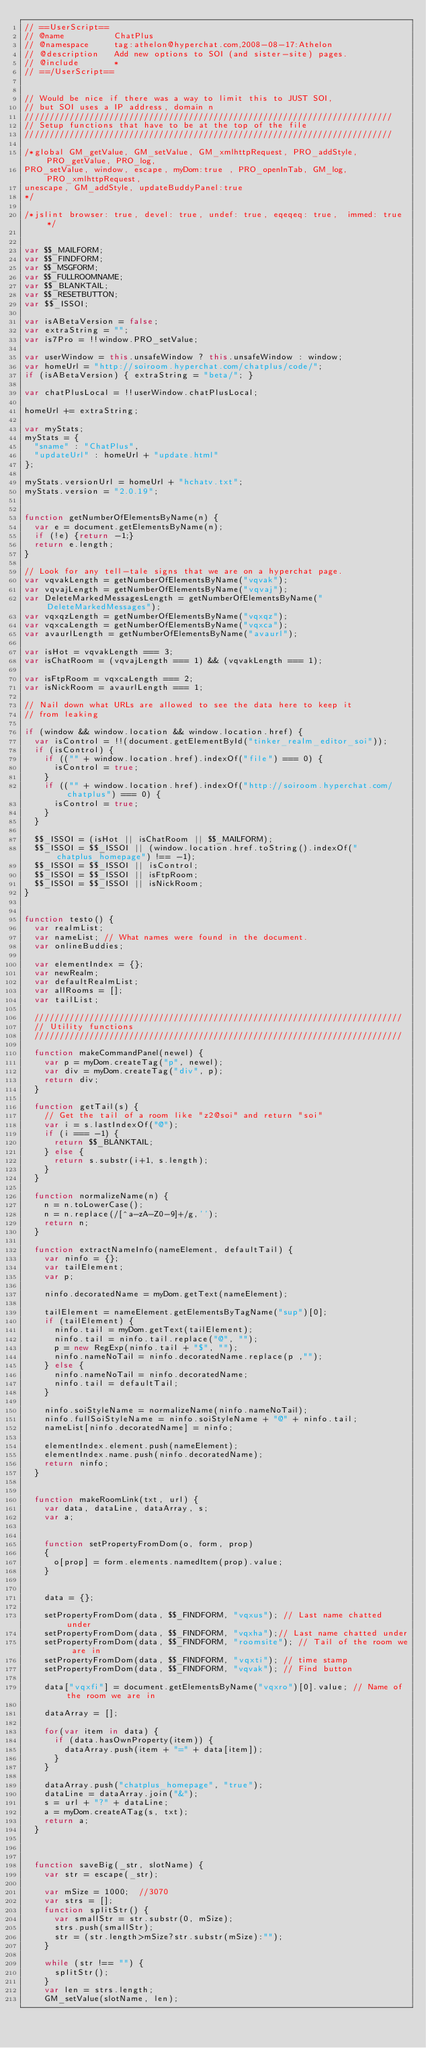<code> <loc_0><loc_0><loc_500><loc_500><_JavaScript_>// ==UserScript==
// @name          ChatPlus
// @namespace     tag:athelon@hyperchat.com,2008-08-17:Athelon
// @description   Add new options to SOI (and sister-site) pages.
// @include       *
// ==/UserScript==


// Would be nice if there was a way to limit this to JUST SOI,
// but SOI uses a IP address, domain n
//////////////////////////////////////////////////////////////////////////
// Setup functions that have to be at the top of the file
//////////////////////////////////////////////////////////////////////////

/*global GM_getValue, GM_setValue, GM_xmlhttpRequest, PRO_addStyle, PRO_getValue, PRO_log,
PRO_setValue, window, escape, myDom:true , PRO_openInTab, GM_log, PRO_xmlhttpRequest,
unescape, GM_addStyle, updateBuddyPanel:true
*/

/*jslint browser: true, devel: true, undef: true, eqeqeq: true,  immed: true */


var $$_MAILFORM;
var $$_FINDFORM;
var $$_MSGFORM;
var $$_FULLROOMNAME;
var $$_BLANKTAIL;
var $$_RESETBUTTON;
var $$_ISSOI;

var isABetaVersion = false;
var extraString = "";
var is7Pro = !!window.PRO_setValue;

var userWindow = this.unsafeWindow ? this.unsafeWindow : window;
var homeUrl = "http://soiroom.hyperchat.com/chatplus/code/";
if (isABetaVersion) { extraString = "beta/"; }

var chatPlusLocal = !!userWindow.chatPlusLocal;

homeUrl += extraString;

var myStats;
myStats = {
  "sname" : "ChatPlus",
  "updateUrl" : homeUrl + "update.html"
};

myStats.versionUrl = homeUrl + "hchatv.txt";
myStats.version = "2.0.19";


function getNumberOfElementsByName(n) {
  var e = document.getElementsByName(n);
  if (!e) {return -1;}
  return e.length;
}

// Look for any tell-tale signs that we are on a hyperchat page.
var vqvakLength = getNumberOfElementsByName("vqvak");
var vqvajLength = getNumberOfElementsByName("vqvaj");
var DeleteMarkedMessagesLength = getNumberOfElementsByName("DeleteMarkedMessages");
var vqxqzLength = getNumberOfElementsByName("vqxqz");
var vqxcaLength = getNumberOfElementsByName("vqxca");
var avaurlLength = getNumberOfElementsByName("avaurl");

var isHot = vqvakLength === 3;
var isChatRoom = (vqvajLength === 1) && (vqvakLength === 1);

var isFtpRoom = vqxcaLength === 2;
var isNickRoom = avaurlLength === 1;

// Nail down what URLs are allowed to see the data here to keep it
// from leaking

if (window && window.location && window.location.href) {
  var isControl = !!(document.getElementById("tinker_realm_editor_soi"));
  if (isControl) {
    if (("" + window.location.href).indexOf("file") === 0) {
      isControl = true;
    }
    if (("" + window.location.href).indexOf("http://soiroom.hyperchat.com/chatplus") === 0) {
      isControl = true;
    }
  }
  
  $$_ISSOI = (isHot || isChatRoom || $$_MAILFORM);
  $$_ISSOI = $$_ISSOI || (window.location.href.toString().indexOf("chatplus_homepage") !== -1);
  $$_ISSOI = $$_ISSOI || isControl;
  $$_ISSOI = $$_ISSOI || isFtpRoom;
  $$_ISSOI = $$_ISSOI || isNickRoom;
}


function testo() {
  var realmList;
  var nameList; // What names were found in the document.
  var onlineBuddies;
  
  var elementIndex = {};
  var newRealm;
  var defaultRealmList;
  var allRooms = [];
  var tailList;
  
  //////////////////////////////////////////////////////////////////////////
  // Utility functions
  //////////////////////////////////////////////////////////////////////////
  
  function makeCommandPanel(newel) {
    var p = myDom.createTag("p", newel);
    var div = myDom.createTag("div", p);
    return div;
  }
  
  function getTail(s) {
    // Get the tail of a room like "z2@soi" and return "soi"
    var i = s.lastIndexOf("@");
    if (i === -1) {
      return $$_BLANKTAIL;
    } else {
      return s.substr(i+1, s.length);
    }
  }
  
  function normalizeName(n) {
    n = n.toLowerCase();
    n = n.replace(/[^a-zA-Z0-9]+/g,'');
    return n;
  }
    
  function extractNameInfo(nameElement, defaultTail) {
    var ninfo = {};
    var tailElement;
    var p;
    
    ninfo.decoratedName = myDom.getText(nameElement);
    
    tailElement = nameElement.getElementsByTagName("sup")[0];
    if (tailElement) {
      ninfo.tail = myDom.getText(tailElement);
      ninfo.tail = ninfo.tail.replace("@", "");
      p = new RegExp(ninfo.tail + "$", "");
      ninfo.nameNoTail = ninfo.decoratedName.replace(p ,"");
    } else {
      ninfo.nameNoTail = ninfo.decoratedName;
      ninfo.tail = defaultTail;
    }
    
    ninfo.soiStyleName = normalizeName(ninfo.nameNoTail);
    ninfo.fullSoiStyleName = ninfo.soiStyleName + "@" + ninfo.tail;
    nameList[ninfo.decoratedName] = ninfo;
    
    elementIndex.element.push(nameElement);
    elementIndex.name.push(ninfo.decoratedName);
    return ninfo;
  }
  
  
  function makeRoomLink(txt, url) {
    var data, dataLine, dataArray, s;
    var a;
    
    
    function setPropertyFromDom(o, form, prop)
    {
      o[prop] = form.elements.namedItem(prop).value;
    }
    
    
    data = {};
    
    setPropertyFromDom(data, $$_FINDFORM, "vqxus"); // Last name chatted under
    setPropertyFromDom(data, $$_FINDFORM, "vqxha");// Last name chatted under
    setPropertyFromDom(data, $$_FINDFORM, "roomsite"); // Tail of the room we are in
    setPropertyFromDom(data, $$_FINDFORM, "vqxti"); // time stamp
    setPropertyFromDom(data, $$_FINDFORM, "vqvak"); // Find button
    
    data["vqxfi"] = document.getElementsByName("vqxro")[0].value; // Name of the room we are in
    
    dataArray = [];
    
    for(var item in data) {
      if (data.hasOwnProperty(item)) {
        dataArray.push(item + "=" + data[item]);
      }
    }
    
    dataArray.push("chatplus_homepage", "true");
    dataLine = dataArray.join("&");
    s = url + "?" + dataLine;
    a = myDom.createATag(s, txt);
    return a;
  }
  
  
  
  function saveBig(_str, slotName) {
    var str = escape(_str);
    
    var mSize = 1000;  //3070
    var strs = [];
    function splitStr() {
      var smallStr = str.substr(0, mSize);
      strs.push(smallStr);
      str = (str.length>mSize?str.substr(mSize):"");
    }
    
    while (str !== "") {
      splitStr();
    }
    var len = strs.length;
    GM_setValue(slotName, len);</code> 